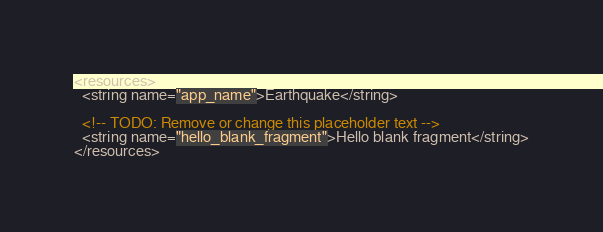<code> <loc_0><loc_0><loc_500><loc_500><_XML_><resources>
  <string name="app_name">Earthquake</string>

  <!-- TODO: Remove or change this placeholder text -->
  <string name="hello_blank_fragment">Hello blank fragment</string>
</resources>
</code> 